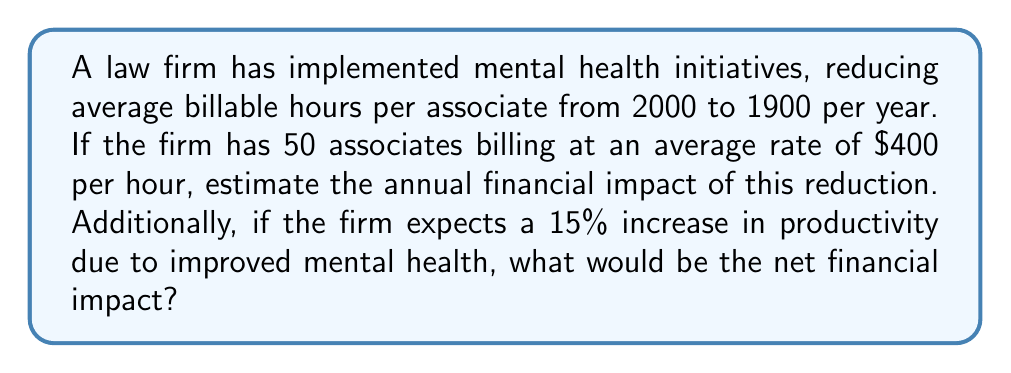What is the answer to this math problem? 1. Calculate the reduction in billable hours per associate:
   $2000 - 1900 = 100$ hours

2. Calculate the total reduction in billable hours for all associates:
   $100 \text{ hours} \times 50 \text{ associates} = 5000$ hours

3. Calculate the gross financial impact:
   $5000 \text{ hours} \times \$400 \text{ per hour} = \$2,000,000$

4. Calculate the productivity increase:
   $1900 \text{ hours} \times 1.15 = 2185$ hours per associate

5. Calculate the net increase in billable hours per associate:
   $2185 - 2000 = 185$ hours

6. Calculate the total increase in billable hours for all associates:
   $185 \text{ hours} \times 50 \text{ associates} = 9250$ hours

7. Calculate the financial benefit of increased productivity:
   $9250 \text{ hours} \times \$400 \text{ per hour} = \$3,700,000$

8. Calculate the net financial impact:
   $\$3,700,000 - \$2,000,000 = \$1,700,000$
Answer: $\$1,700,000$ net positive impact 